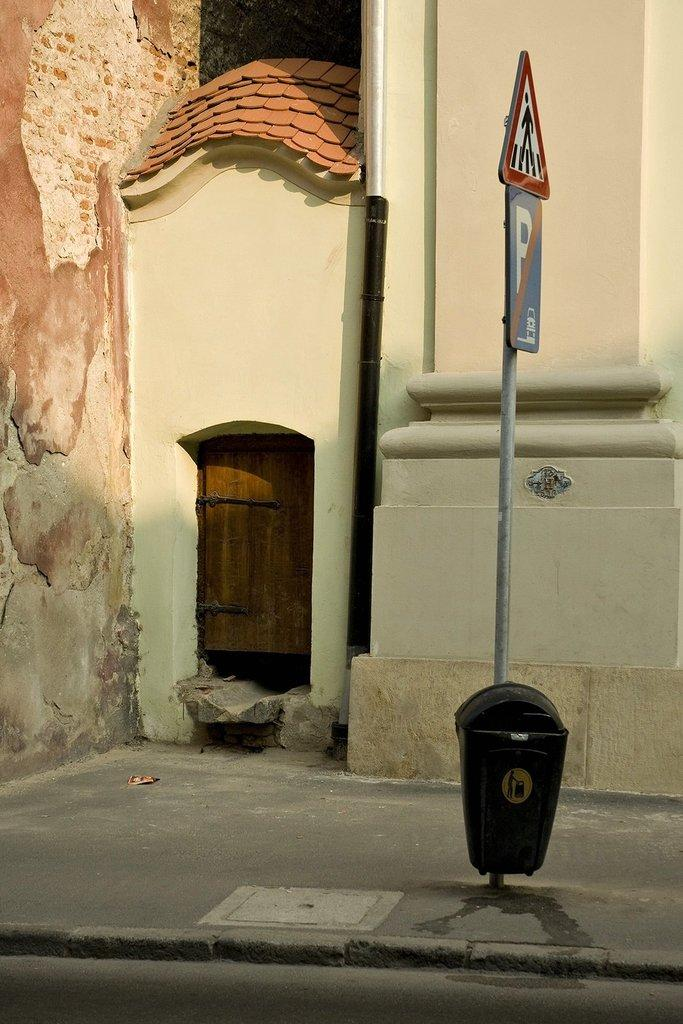What is the main object in the image? There is a pole in the image. What is attached to the pole? The pole has two sign boards above it. What is located below the pole? There is a dustbin below the pole. What can be seen in the background of the image? There is a building in the background of the image. Can you tell me how many lawyers are present in the image? There are no lawyers present in the image. What type of bird can be seen flying near the pole in the image? There are no birds visible in the image. 